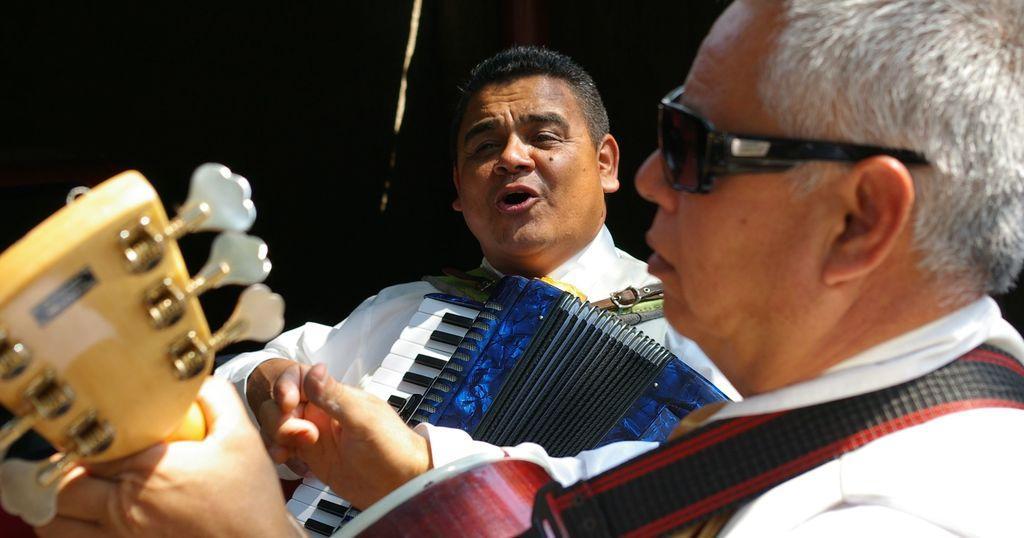How would you summarize this image in a sentence or two? In the image we can see two persons holding some musical instrument. And the front person wearing glasses. And the second person singing which we can see on his face. 